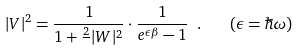Convert formula to latex. <formula><loc_0><loc_0><loc_500><loc_500>| V | ^ { 2 } = \frac { 1 } { 1 + \frac { 2 } { } | W | ^ { 2 } } \cdot \frac { 1 } { e ^ { \epsilon \beta } - 1 } \ . \quad ( \epsilon = \hbar { \omega } )</formula> 